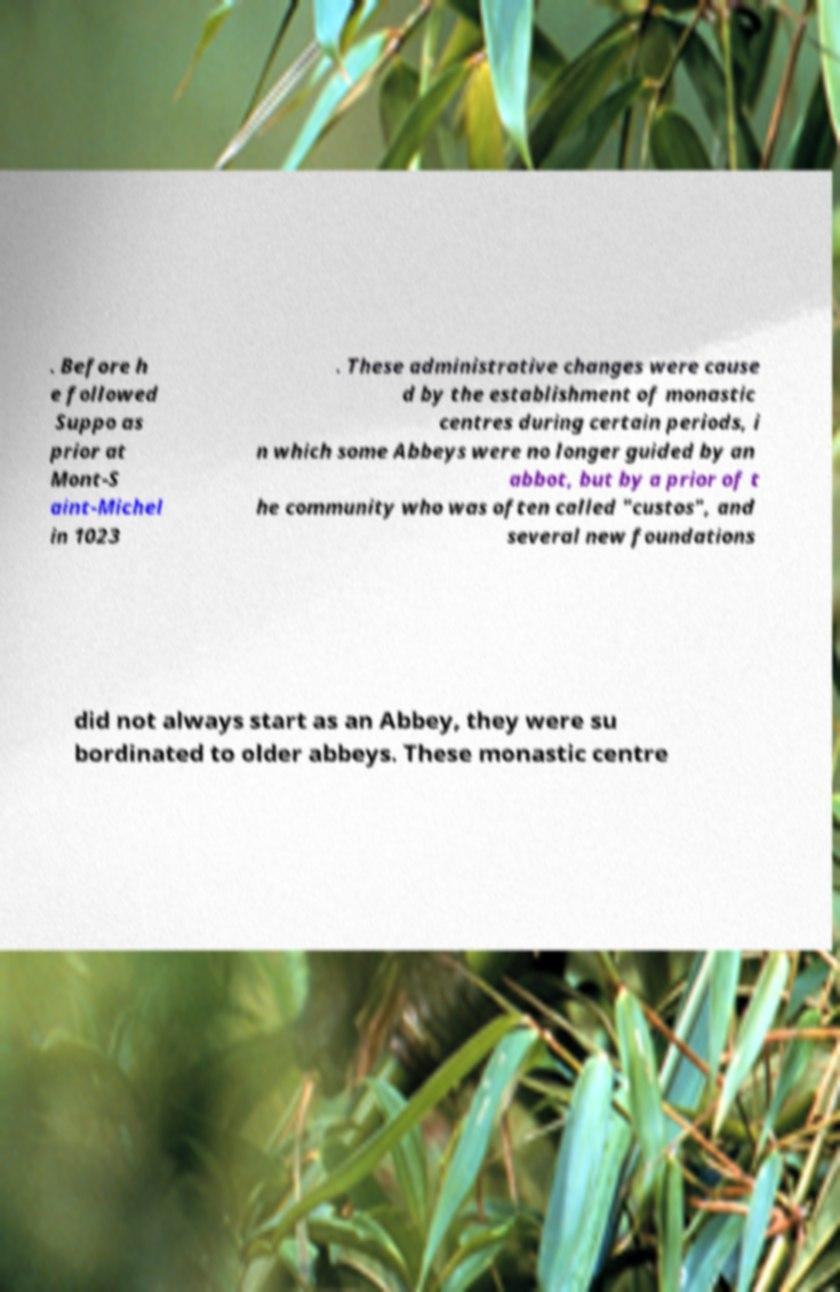Could you assist in decoding the text presented in this image and type it out clearly? . Before h e followed Suppo as prior at Mont-S aint-Michel in 1023 . These administrative changes were cause d by the establishment of monastic centres during certain periods, i n which some Abbeys were no longer guided by an abbot, but by a prior of t he community who was often called "custos", and several new foundations did not always start as an Abbey, they were su bordinated to older abbeys. These monastic centre 